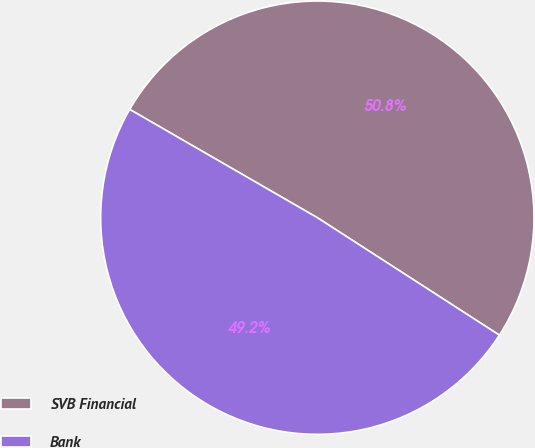Convert chart. <chart><loc_0><loc_0><loc_500><loc_500><pie_chart><fcel>SVB Financial<fcel>Bank<nl><fcel>50.79%<fcel>49.21%<nl></chart> 